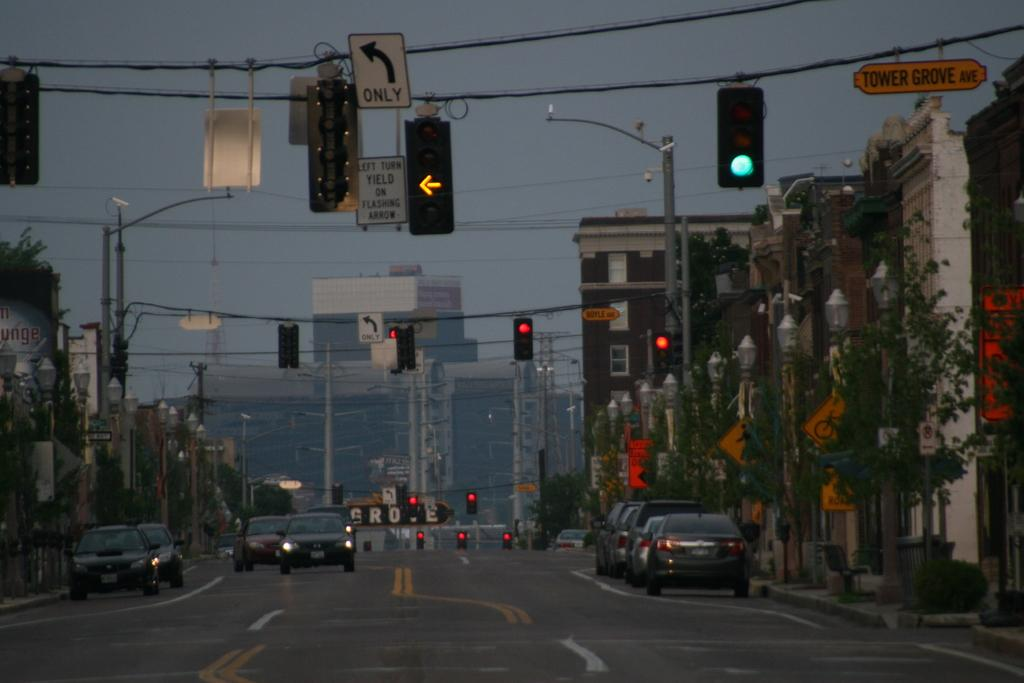<image>
Render a clear and concise summary of the photo. A yellow sign for Tower Grove Avenue hangs over the street near a traffic light. 